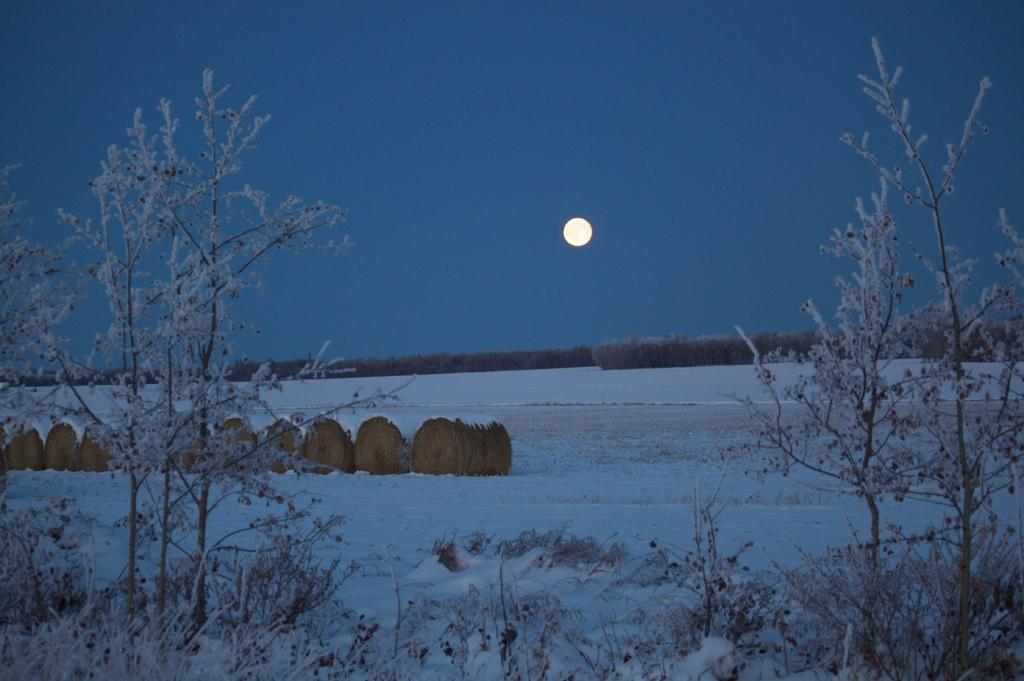What type of vegetation can be seen in the image? There are trees and plants in the image. What is the ground covered with in the image? There is snow on the ground in the image. What objects can be seen on the ground in the image? There are objects on the ground in the image. What celestial body is visible in the background of the image? The moon is visible in the background of the image. What else can be seen in the background of the image? The sky is visible in the background of the image. What is the cast of characters in the image? There are no characters or cast present in the image; it features trees, plants, snow, objects, the moon, and the sky. What route is the vehicle taking in the image? There is no vehicle or route present in the image. 